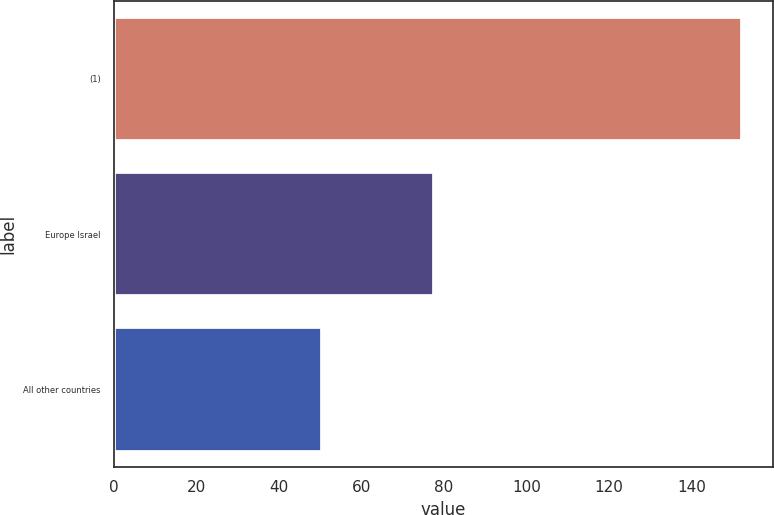Convert chart. <chart><loc_0><loc_0><loc_500><loc_500><bar_chart><fcel>(1)<fcel>Europe Israel<fcel>All other countries<nl><fcel>152.3<fcel>77.6<fcel>50.5<nl></chart> 